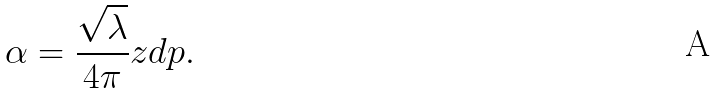<formula> <loc_0><loc_0><loc_500><loc_500>\alpha = \frac { \sqrt { \lambda } } { 4 \pi } z d p .</formula> 